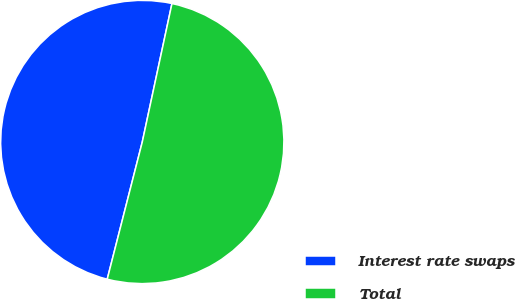<chart> <loc_0><loc_0><loc_500><loc_500><pie_chart><fcel>Interest rate swaps<fcel>Total<nl><fcel>49.38%<fcel>50.62%<nl></chart> 